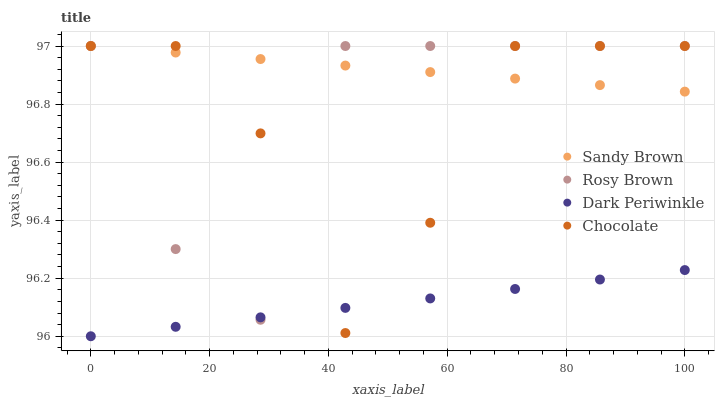Does Dark Periwinkle have the minimum area under the curve?
Answer yes or no. Yes. Does Sandy Brown have the maximum area under the curve?
Answer yes or no. Yes. Does Sandy Brown have the minimum area under the curve?
Answer yes or no. No. Does Dark Periwinkle have the maximum area under the curve?
Answer yes or no. No. Is Sandy Brown the smoothest?
Answer yes or no. Yes. Is Chocolate the roughest?
Answer yes or no. Yes. Is Dark Periwinkle the smoothest?
Answer yes or no. No. Is Dark Periwinkle the roughest?
Answer yes or no. No. Does Dark Periwinkle have the lowest value?
Answer yes or no. Yes. Does Sandy Brown have the lowest value?
Answer yes or no. No. Does Chocolate have the highest value?
Answer yes or no. Yes. Does Dark Periwinkle have the highest value?
Answer yes or no. No. Is Dark Periwinkle less than Sandy Brown?
Answer yes or no. Yes. Is Sandy Brown greater than Dark Periwinkle?
Answer yes or no. Yes. Does Rosy Brown intersect Chocolate?
Answer yes or no. Yes. Is Rosy Brown less than Chocolate?
Answer yes or no. No. Is Rosy Brown greater than Chocolate?
Answer yes or no. No. Does Dark Periwinkle intersect Sandy Brown?
Answer yes or no. No. 